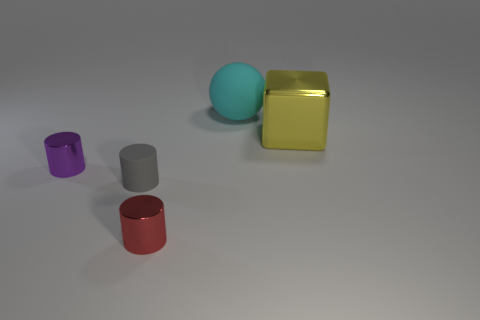Are there any other things that have the same size as the ball?
Your answer should be very brief. Yes. What number of other things are the same shape as the tiny gray thing?
Your answer should be compact. 2. There is a object that is behind the small purple shiny object and in front of the cyan thing; what shape is it?
Your answer should be very brief. Cube. How big is the matte thing to the left of the tiny red cylinder?
Give a very brief answer. Small. Is the size of the red metallic cylinder the same as the cyan matte thing?
Your response must be concise. No. Is the number of red metal cylinders in front of the tiny gray cylinder less than the number of yellow metallic things left of the red metal thing?
Provide a succinct answer. No. There is a shiny thing that is behind the tiny gray matte object and to the right of the small gray object; how big is it?
Ensure brevity in your answer.  Large. Is there a gray rubber cylinder left of the metal thing that is left of the metallic thing that is in front of the gray cylinder?
Keep it short and to the point. No. Are there any metal blocks?
Your response must be concise. Yes. Is the number of small red metallic cylinders behind the yellow thing greater than the number of large matte spheres behind the cyan sphere?
Provide a succinct answer. No. 